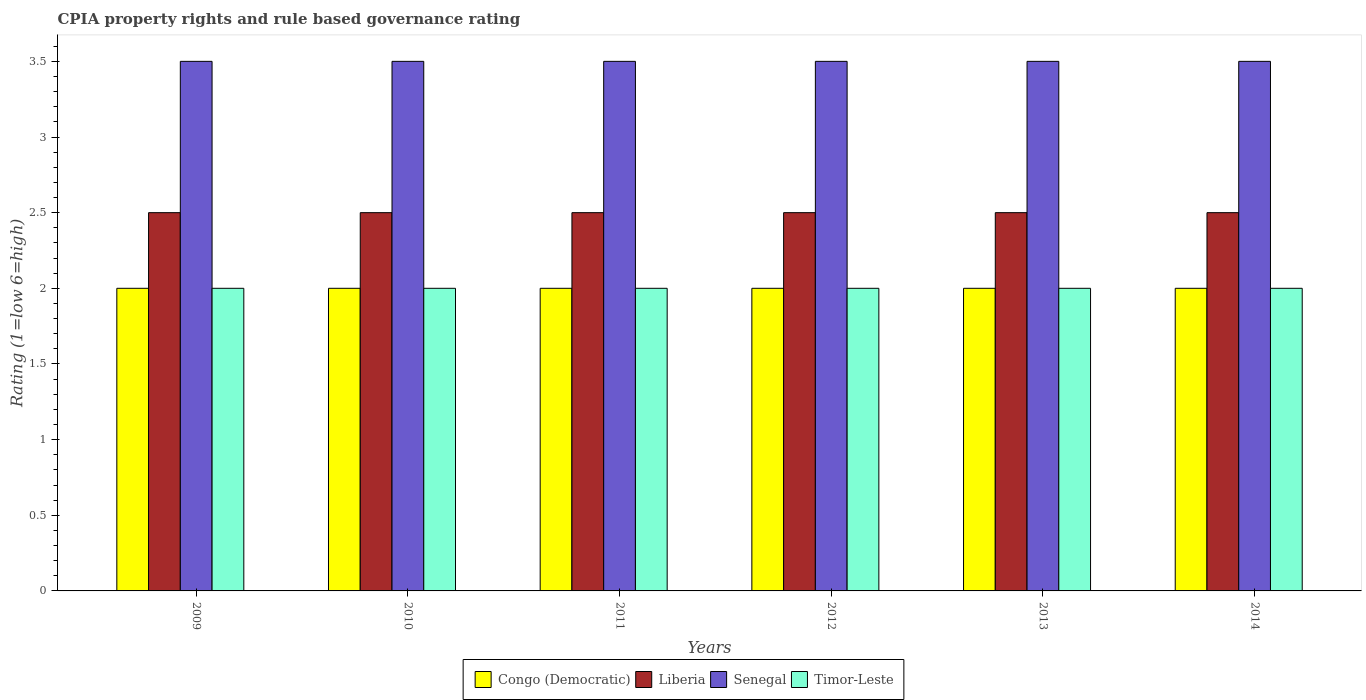How many groups of bars are there?
Your answer should be very brief. 6. In how many cases, is the number of bars for a given year not equal to the number of legend labels?
Ensure brevity in your answer.  0. Across all years, what is the minimum CPIA rating in Congo (Democratic)?
Provide a succinct answer. 2. What is the total CPIA rating in Timor-Leste in the graph?
Make the answer very short. 12. What is the difference between the CPIA rating in Congo (Democratic) in 2014 and the CPIA rating in Liberia in 2009?
Provide a short and direct response. -0.5. In the year 2014, what is the difference between the CPIA rating in Liberia and CPIA rating in Timor-Leste?
Your answer should be very brief. 0.5. What is the ratio of the CPIA rating in Liberia in 2009 to that in 2010?
Your response must be concise. 1. Is the difference between the CPIA rating in Liberia in 2009 and 2012 greater than the difference between the CPIA rating in Timor-Leste in 2009 and 2012?
Give a very brief answer. No. What is the difference between the highest and the second highest CPIA rating in Congo (Democratic)?
Make the answer very short. 0. What is the difference between the highest and the lowest CPIA rating in Congo (Democratic)?
Ensure brevity in your answer.  0. Is it the case that in every year, the sum of the CPIA rating in Congo (Democratic) and CPIA rating in Senegal is greater than the sum of CPIA rating in Liberia and CPIA rating in Timor-Leste?
Your answer should be very brief. Yes. What does the 3rd bar from the left in 2011 represents?
Provide a succinct answer. Senegal. What does the 2nd bar from the right in 2014 represents?
Make the answer very short. Senegal. Is it the case that in every year, the sum of the CPIA rating in Timor-Leste and CPIA rating in Congo (Democratic) is greater than the CPIA rating in Liberia?
Provide a succinct answer. Yes. How many bars are there?
Make the answer very short. 24. Are all the bars in the graph horizontal?
Make the answer very short. No. How many years are there in the graph?
Provide a succinct answer. 6. Are the values on the major ticks of Y-axis written in scientific E-notation?
Keep it short and to the point. No. Does the graph contain any zero values?
Keep it short and to the point. No. Where does the legend appear in the graph?
Your answer should be compact. Bottom center. How many legend labels are there?
Make the answer very short. 4. How are the legend labels stacked?
Give a very brief answer. Horizontal. What is the title of the graph?
Offer a very short reply. CPIA property rights and rule based governance rating. Does "Vanuatu" appear as one of the legend labels in the graph?
Your response must be concise. No. What is the label or title of the Y-axis?
Provide a short and direct response. Rating (1=low 6=high). What is the Rating (1=low 6=high) of Congo (Democratic) in 2009?
Make the answer very short. 2. What is the Rating (1=low 6=high) of Senegal in 2009?
Ensure brevity in your answer.  3.5. What is the Rating (1=low 6=high) of Timor-Leste in 2009?
Your answer should be compact. 2. What is the Rating (1=low 6=high) of Congo (Democratic) in 2010?
Give a very brief answer. 2. What is the Rating (1=low 6=high) in Senegal in 2011?
Keep it short and to the point. 3.5. What is the Rating (1=low 6=high) of Congo (Democratic) in 2012?
Offer a very short reply. 2. What is the Rating (1=low 6=high) in Senegal in 2012?
Make the answer very short. 3.5. What is the Rating (1=low 6=high) in Timor-Leste in 2012?
Offer a very short reply. 2. What is the Rating (1=low 6=high) of Timor-Leste in 2014?
Provide a short and direct response. 2. Across all years, what is the maximum Rating (1=low 6=high) in Liberia?
Give a very brief answer. 2.5. Across all years, what is the maximum Rating (1=low 6=high) of Timor-Leste?
Offer a very short reply. 2. Across all years, what is the minimum Rating (1=low 6=high) in Liberia?
Provide a short and direct response. 2.5. What is the total Rating (1=low 6=high) in Liberia in the graph?
Provide a succinct answer. 15. What is the difference between the Rating (1=low 6=high) in Liberia in 2009 and that in 2010?
Ensure brevity in your answer.  0. What is the difference between the Rating (1=low 6=high) in Timor-Leste in 2009 and that in 2010?
Your answer should be compact. 0. What is the difference between the Rating (1=low 6=high) of Senegal in 2009 and that in 2011?
Provide a short and direct response. 0. What is the difference between the Rating (1=low 6=high) in Congo (Democratic) in 2009 and that in 2012?
Your response must be concise. 0. What is the difference between the Rating (1=low 6=high) in Congo (Democratic) in 2009 and that in 2013?
Your answer should be very brief. 0. What is the difference between the Rating (1=low 6=high) in Senegal in 2009 and that in 2013?
Offer a terse response. 0. What is the difference between the Rating (1=low 6=high) of Liberia in 2009 and that in 2014?
Your answer should be compact. 0. What is the difference between the Rating (1=low 6=high) of Congo (Democratic) in 2010 and that in 2011?
Your response must be concise. 0. What is the difference between the Rating (1=low 6=high) of Timor-Leste in 2010 and that in 2011?
Give a very brief answer. 0. What is the difference between the Rating (1=low 6=high) in Senegal in 2010 and that in 2012?
Provide a succinct answer. 0. What is the difference between the Rating (1=low 6=high) of Senegal in 2010 and that in 2014?
Give a very brief answer. 0. What is the difference between the Rating (1=low 6=high) in Timor-Leste in 2010 and that in 2014?
Your answer should be very brief. 0. What is the difference between the Rating (1=low 6=high) in Congo (Democratic) in 2011 and that in 2012?
Make the answer very short. 0. What is the difference between the Rating (1=low 6=high) of Timor-Leste in 2011 and that in 2012?
Ensure brevity in your answer.  0. What is the difference between the Rating (1=low 6=high) of Liberia in 2011 and that in 2013?
Provide a short and direct response. 0. What is the difference between the Rating (1=low 6=high) of Congo (Democratic) in 2011 and that in 2014?
Keep it short and to the point. 0. What is the difference between the Rating (1=low 6=high) in Liberia in 2011 and that in 2014?
Make the answer very short. 0. What is the difference between the Rating (1=low 6=high) in Senegal in 2012 and that in 2013?
Offer a terse response. 0. What is the difference between the Rating (1=low 6=high) in Timor-Leste in 2012 and that in 2013?
Your answer should be compact. 0. What is the difference between the Rating (1=low 6=high) in Congo (Democratic) in 2012 and that in 2014?
Your answer should be compact. 0. What is the difference between the Rating (1=low 6=high) of Timor-Leste in 2012 and that in 2014?
Provide a succinct answer. 0. What is the difference between the Rating (1=low 6=high) in Congo (Democratic) in 2013 and that in 2014?
Give a very brief answer. 0. What is the difference between the Rating (1=low 6=high) in Senegal in 2013 and that in 2014?
Your response must be concise. 0. What is the difference between the Rating (1=low 6=high) of Senegal in 2009 and the Rating (1=low 6=high) of Timor-Leste in 2010?
Give a very brief answer. 1.5. What is the difference between the Rating (1=low 6=high) of Congo (Democratic) in 2009 and the Rating (1=low 6=high) of Timor-Leste in 2011?
Your answer should be very brief. 0. What is the difference between the Rating (1=low 6=high) of Liberia in 2009 and the Rating (1=low 6=high) of Senegal in 2011?
Your answer should be compact. -1. What is the difference between the Rating (1=low 6=high) in Liberia in 2009 and the Rating (1=low 6=high) in Timor-Leste in 2011?
Give a very brief answer. 0.5. What is the difference between the Rating (1=low 6=high) in Congo (Democratic) in 2009 and the Rating (1=low 6=high) in Liberia in 2012?
Ensure brevity in your answer.  -0.5. What is the difference between the Rating (1=low 6=high) of Congo (Democratic) in 2009 and the Rating (1=low 6=high) of Timor-Leste in 2012?
Provide a short and direct response. 0. What is the difference between the Rating (1=low 6=high) of Congo (Democratic) in 2009 and the Rating (1=low 6=high) of Senegal in 2013?
Your answer should be very brief. -1.5. What is the difference between the Rating (1=low 6=high) in Congo (Democratic) in 2009 and the Rating (1=low 6=high) in Timor-Leste in 2013?
Ensure brevity in your answer.  0. What is the difference between the Rating (1=low 6=high) in Liberia in 2009 and the Rating (1=low 6=high) in Senegal in 2013?
Give a very brief answer. -1. What is the difference between the Rating (1=low 6=high) in Congo (Democratic) in 2009 and the Rating (1=low 6=high) in Liberia in 2014?
Provide a succinct answer. -0.5. What is the difference between the Rating (1=low 6=high) of Congo (Democratic) in 2009 and the Rating (1=low 6=high) of Senegal in 2014?
Offer a very short reply. -1.5. What is the difference between the Rating (1=low 6=high) in Congo (Democratic) in 2010 and the Rating (1=low 6=high) in Liberia in 2011?
Provide a succinct answer. -0.5. What is the difference between the Rating (1=low 6=high) of Congo (Democratic) in 2010 and the Rating (1=low 6=high) of Senegal in 2011?
Your response must be concise. -1.5. What is the difference between the Rating (1=low 6=high) in Congo (Democratic) in 2010 and the Rating (1=low 6=high) in Timor-Leste in 2011?
Your answer should be compact. 0. What is the difference between the Rating (1=low 6=high) of Liberia in 2010 and the Rating (1=low 6=high) of Senegal in 2011?
Your response must be concise. -1. What is the difference between the Rating (1=low 6=high) of Liberia in 2010 and the Rating (1=low 6=high) of Timor-Leste in 2011?
Provide a short and direct response. 0.5. What is the difference between the Rating (1=low 6=high) of Senegal in 2010 and the Rating (1=low 6=high) of Timor-Leste in 2011?
Keep it short and to the point. 1.5. What is the difference between the Rating (1=low 6=high) in Congo (Democratic) in 2010 and the Rating (1=low 6=high) in Timor-Leste in 2012?
Make the answer very short. 0. What is the difference between the Rating (1=low 6=high) of Liberia in 2010 and the Rating (1=low 6=high) of Timor-Leste in 2012?
Keep it short and to the point. 0.5. What is the difference between the Rating (1=low 6=high) of Congo (Democratic) in 2010 and the Rating (1=low 6=high) of Senegal in 2013?
Give a very brief answer. -1.5. What is the difference between the Rating (1=low 6=high) in Congo (Democratic) in 2010 and the Rating (1=low 6=high) in Timor-Leste in 2013?
Keep it short and to the point. 0. What is the difference between the Rating (1=low 6=high) in Liberia in 2010 and the Rating (1=low 6=high) in Timor-Leste in 2013?
Keep it short and to the point. 0.5. What is the difference between the Rating (1=low 6=high) in Liberia in 2010 and the Rating (1=low 6=high) in Senegal in 2014?
Give a very brief answer. -1. What is the difference between the Rating (1=low 6=high) of Liberia in 2010 and the Rating (1=low 6=high) of Timor-Leste in 2014?
Your answer should be very brief. 0.5. What is the difference between the Rating (1=low 6=high) in Senegal in 2010 and the Rating (1=low 6=high) in Timor-Leste in 2014?
Give a very brief answer. 1.5. What is the difference between the Rating (1=low 6=high) of Congo (Democratic) in 2011 and the Rating (1=low 6=high) of Liberia in 2012?
Provide a succinct answer. -0.5. What is the difference between the Rating (1=low 6=high) in Congo (Democratic) in 2011 and the Rating (1=low 6=high) in Senegal in 2012?
Provide a short and direct response. -1.5. What is the difference between the Rating (1=low 6=high) of Congo (Democratic) in 2011 and the Rating (1=low 6=high) of Timor-Leste in 2012?
Your answer should be very brief. 0. What is the difference between the Rating (1=low 6=high) of Senegal in 2011 and the Rating (1=low 6=high) of Timor-Leste in 2012?
Your answer should be very brief. 1.5. What is the difference between the Rating (1=low 6=high) in Congo (Democratic) in 2011 and the Rating (1=low 6=high) in Liberia in 2013?
Give a very brief answer. -0.5. What is the difference between the Rating (1=low 6=high) in Congo (Democratic) in 2011 and the Rating (1=low 6=high) in Timor-Leste in 2013?
Your answer should be very brief. 0. What is the difference between the Rating (1=low 6=high) of Liberia in 2011 and the Rating (1=low 6=high) of Senegal in 2013?
Your answer should be compact. -1. What is the difference between the Rating (1=low 6=high) of Senegal in 2011 and the Rating (1=low 6=high) of Timor-Leste in 2013?
Your response must be concise. 1.5. What is the difference between the Rating (1=low 6=high) in Congo (Democratic) in 2011 and the Rating (1=low 6=high) in Senegal in 2014?
Offer a terse response. -1.5. What is the difference between the Rating (1=low 6=high) in Liberia in 2011 and the Rating (1=low 6=high) in Senegal in 2014?
Provide a short and direct response. -1. What is the difference between the Rating (1=low 6=high) of Congo (Democratic) in 2012 and the Rating (1=low 6=high) of Liberia in 2013?
Ensure brevity in your answer.  -0.5. What is the difference between the Rating (1=low 6=high) in Congo (Democratic) in 2012 and the Rating (1=low 6=high) in Senegal in 2013?
Keep it short and to the point. -1.5. What is the difference between the Rating (1=low 6=high) of Liberia in 2012 and the Rating (1=low 6=high) of Senegal in 2013?
Provide a succinct answer. -1. What is the difference between the Rating (1=low 6=high) of Liberia in 2012 and the Rating (1=low 6=high) of Timor-Leste in 2013?
Offer a terse response. 0.5. What is the difference between the Rating (1=low 6=high) in Congo (Democratic) in 2012 and the Rating (1=low 6=high) in Senegal in 2014?
Give a very brief answer. -1.5. What is the difference between the Rating (1=low 6=high) in Liberia in 2012 and the Rating (1=low 6=high) in Senegal in 2014?
Make the answer very short. -1. What is the difference between the Rating (1=low 6=high) in Senegal in 2012 and the Rating (1=low 6=high) in Timor-Leste in 2014?
Offer a very short reply. 1.5. What is the difference between the Rating (1=low 6=high) in Congo (Democratic) in 2013 and the Rating (1=low 6=high) in Liberia in 2014?
Offer a terse response. -0.5. What is the difference between the Rating (1=low 6=high) in Congo (Democratic) in 2013 and the Rating (1=low 6=high) in Timor-Leste in 2014?
Your answer should be compact. 0. What is the difference between the Rating (1=low 6=high) of Liberia in 2013 and the Rating (1=low 6=high) of Senegal in 2014?
Give a very brief answer. -1. What is the difference between the Rating (1=low 6=high) of Liberia in 2013 and the Rating (1=low 6=high) of Timor-Leste in 2014?
Provide a succinct answer. 0.5. What is the difference between the Rating (1=low 6=high) of Senegal in 2013 and the Rating (1=low 6=high) of Timor-Leste in 2014?
Provide a succinct answer. 1.5. What is the average Rating (1=low 6=high) of Senegal per year?
Offer a very short reply. 3.5. What is the average Rating (1=low 6=high) of Timor-Leste per year?
Offer a terse response. 2. In the year 2009, what is the difference between the Rating (1=low 6=high) in Congo (Democratic) and Rating (1=low 6=high) in Timor-Leste?
Your answer should be very brief. 0. In the year 2009, what is the difference between the Rating (1=low 6=high) in Liberia and Rating (1=low 6=high) in Timor-Leste?
Ensure brevity in your answer.  0.5. In the year 2009, what is the difference between the Rating (1=low 6=high) of Senegal and Rating (1=low 6=high) of Timor-Leste?
Provide a succinct answer. 1.5. In the year 2010, what is the difference between the Rating (1=low 6=high) of Congo (Democratic) and Rating (1=low 6=high) of Liberia?
Give a very brief answer. -0.5. In the year 2010, what is the difference between the Rating (1=low 6=high) of Congo (Democratic) and Rating (1=low 6=high) of Senegal?
Offer a terse response. -1.5. In the year 2010, what is the difference between the Rating (1=low 6=high) in Congo (Democratic) and Rating (1=low 6=high) in Timor-Leste?
Give a very brief answer. 0. In the year 2010, what is the difference between the Rating (1=low 6=high) in Senegal and Rating (1=low 6=high) in Timor-Leste?
Give a very brief answer. 1.5. In the year 2012, what is the difference between the Rating (1=low 6=high) of Congo (Democratic) and Rating (1=low 6=high) of Liberia?
Your answer should be compact. -0.5. In the year 2012, what is the difference between the Rating (1=low 6=high) in Congo (Democratic) and Rating (1=low 6=high) in Timor-Leste?
Your response must be concise. 0. In the year 2012, what is the difference between the Rating (1=low 6=high) of Liberia and Rating (1=low 6=high) of Senegal?
Your answer should be very brief. -1. In the year 2012, what is the difference between the Rating (1=low 6=high) of Senegal and Rating (1=low 6=high) of Timor-Leste?
Keep it short and to the point. 1.5. In the year 2013, what is the difference between the Rating (1=low 6=high) in Congo (Democratic) and Rating (1=low 6=high) in Senegal?
Your answer should be compact. -1.5. In the year 2013, what is the difference between the Rating (1=low 6=high) of Congo (Democratic) and Rating (1=low 6=high) of Timor-Leste?
Your response must be concise. 0. In the year 2013, what is the difference between the Rating (1=low 6=high) of Liberia and Rating (1=low 6=high) of Senegal?
Your answer should be very brief. -1. In the year 2013, what is the difference between the Rating (1=low 6=high) in Senegal and Rating (1=low 6=high) in Timor-Leste?
Your response must be concise. 1.5. In the year 2014, what is the difference between the Rating (1=low 6=high) of Congo (Democratic) and Rating (1=low 6=high) of Senegal?
Your answer should be compact. -1.5. In the year 2014, what is the difference between the Rating (1=low 6=high) of Liberia and Rating (1=low 6=high) of Senegal?
Offer a terse response. -1. In the year 2014, what is the difference between the Rating (1=low 6=high) in Senegal and Rating (1=low 6=high) in Timor-Leste?
Your answer should be compact. 1.5. What is the ratio of the Rating (1=low 6=high) of Senegal in 2009 to that in 2010?
Provide a succinct answer. 1. What is the ratio of the Rating (1=low 6=high) of Liberia in 2009 to that in 2011?
Provide a succinct answer. 1. What is the ratio of the Rating (1=low 6=high) of Timor-Leste in 2009 to that in 2011?
Your answer should be very brief. 1. What is the ratio of the Rating (1=low 6=high) of Senegal in 2009 to that in 2012?
Your answer should be compact. 1. What is the ratio of the Rating (1=low 6=high) of Timor-Leste in 2009 to that in 2012?
Provide a short and direct response. 1. What is the ratio of the Rating (1=low 6=high) in Timor-Leste in 2009 to that in 2013?
Provide a short and direct response. 1. What is the ratio of the Rating (1=low 6=high) in Congo (Democratic) in 2009 to that in 2014?
Give a very brief answer. 1. What is the ratio of the Rating (1=low 6=high) of Liberia in 2009 to that in 2014?
Provide a succinct answer. 1. What is the ratio of the Rating (1=low 6=high) of Senegal in 2009 to that in 2014?
Give a very brief answer. 1. What is the ratio of the Rating (1=low 6=high) of Timor-Leste in 2009 to that in 2014?
Keep it short and to the point. 1. What is the ratio of the Rating (1=low 6=high) in Senegal in 2010 to that in 2011?
Make the answer very short. 1. What is the ratio of the Rating (1=low 6=high) in Timor-Leste in 2010 to that in 2011?
Your answer should be compact. 1. What is the ratio of the Rating (1=low 6=high) of Liberia in 2010 to that in 2012?
Your answer should be very brief. 1. What is the ratio of the Rating (1=low 6=high) in Senegal in 2010 to that in 2012?
Make the answer very short. 1. What is the ratio of the Rating (1=low 6=high) in Senegal in 2010 to that in 2013?
Provide a short and direct response. 1. What is the ratio of the Rating (1=low 6=high) of Timor-Leste in 2010 to that in 2013?
Provide a succinct answer. 1. What is the ratio of the Rating (1=low 6=high) of Congo (Democratic) in 2010 to that in 2014?
Your answer should be compact. 1. What is the ratio of the Rating (1=low 6=high) in Congo (Democratic) in 2011 to that in 2012?
Keep it short and to the point. 1. What is the ratio of the Rating (1=low 6=high) in Senegal in 2011 to that in 2012?
Provide a short and direct response. 1. What is the ratio of the Rating (1=low 6=high) of Timor-Leste in 2011 to that in 2012?
Give a very brief answer. 1. What is the ratio of the Rating (1=low 6=high) in Congo (Democratic) in 2011 to that in 2013?
Make the answer very short. 1. What is the ratio of the Rating (1=low 6=high) in Liberia in 2011 to that in 2013?
Your answer should be very brief. 1. What is the ratio of the Rating (1=low 6=high) of Senegal in 2011 to that in 2013?
Provide a short and direct response. 1. What is the ratio of the Rating (1=low 6=high) of Timor-Leste in 2011 to that in 2013?
Offer a very short reply. 1. What is the ratio of the Rating (1=low 6=high) of Congo (Democratic) in 2011 to that in 2014?
Your response must be concise. 1. What is the ratio of the Rating (1=low 6=high) in Liberia in 2011 to that in 2014?
Ensure brevity in your answer.  1. What is the ratio of the Rating (1=low 6=high) in Senegal in 2011 to that in 2014?
Your response must be concise. 1. What is the ratio of the Rating (1=low 6=high) in Timor-Leste in 2011 to that in 2014?
Give a very brief answer. 1. What is the ratio of the Rating (1=low 6=high) of Senegal in 2012 to that in 2013?
Provide a succinct answer. 1. What is the ratio of the Rating (1=low 6=high) in Timor-Leste in 2012 to that in 2013?
Offer a very short reply. 1. What is the ratio of the Rating (1=low 6=high) in Congo (Democratic) in 2012 to that in 2014?
Ensure brevity in your answer.  1. What is the ratio of the Rating (1=low 6=high) in Liberia in 2012 to that in 2014?
Keep it short and to the point. 1. What is the ratio of the Rating (1=low 6=high) in Liberia in 2013 to that in 2014?
Your answer should be very brief. 1. What is the ratio of the Rating (1=low 6=high) in Senegal in 2013 to that in 2014?
Your response must be concise. 1. What is the ratio of the Rating (1=low 6=high) of Timor-Leste in 2013 to that in 2014?
Keep it short and to the point. 1. What is the difference between the highest and the second highest Rating (1=low 6=high) of Senegal?
Ensure brevity in your answer.  0. What is the difference between the highest and the lowest Rating (1=low 6=high) of Congo (Democratic)?
Your answer should be compact. 0. What is the difference between the highest and the lowest Rating (1=low 6=high) of Liberia?
Provide a short and direct response. 0. What is the difference between the highest and the lowest Rating (1=low 6=high) of Senegal?
Offer a very short reply. 0. 